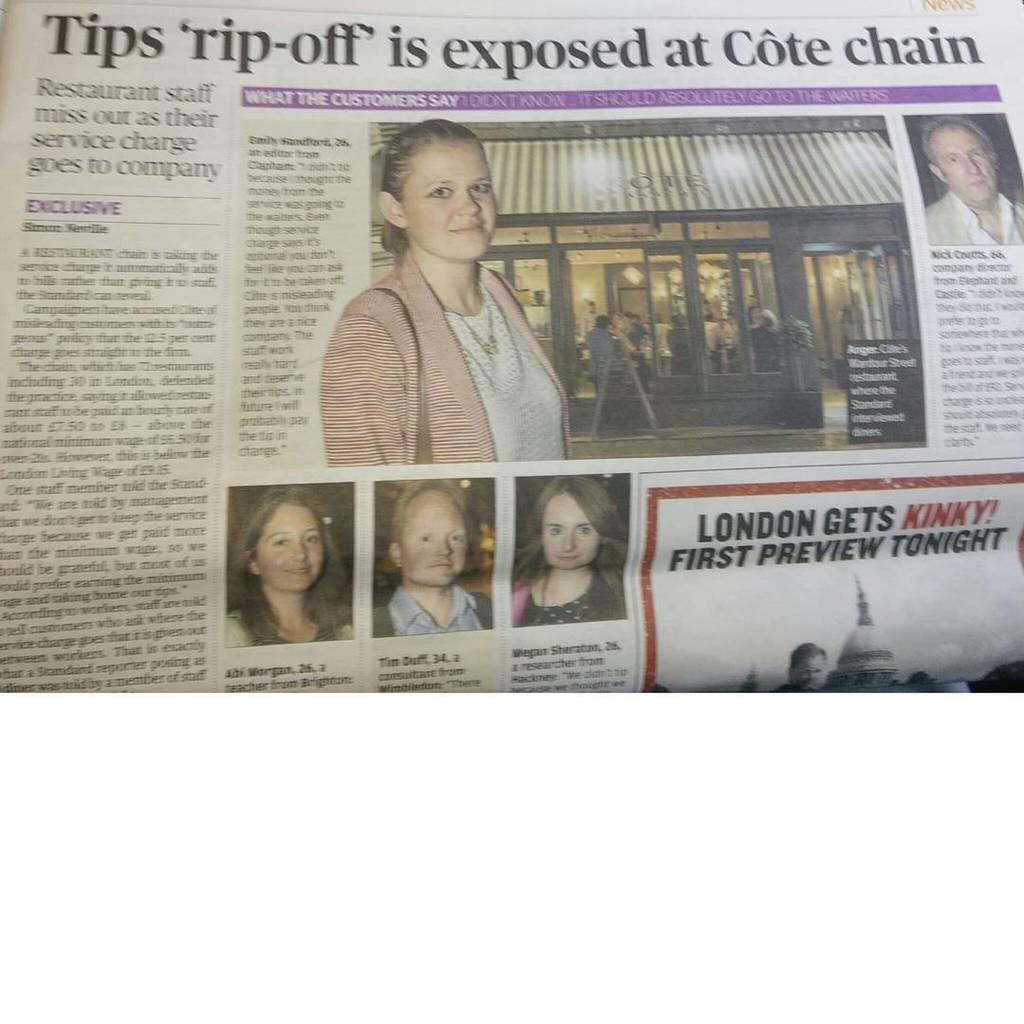Could you give a brief overview of what you see in this image? In this picture we can see a newspaper with some images and text written on it. 